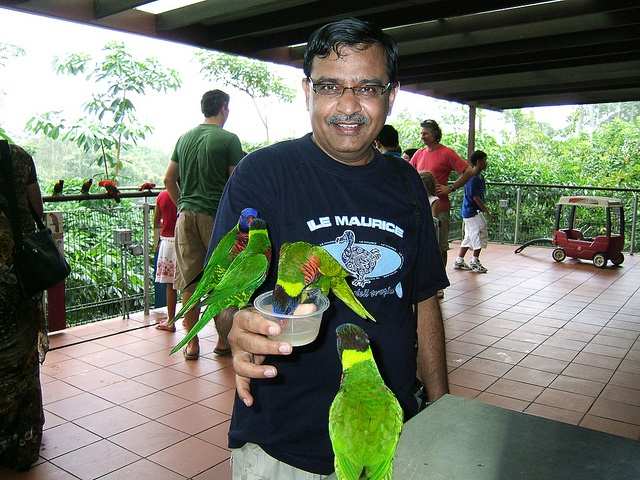Describe the objects in this image and their specific colors. I can see people in black, gray, and tan tones, people in black, gray, ivory, and darkgreen tones, people in black, gray, and darkgreen tones, bird in black, green, lime, and lightgreen tones, and bird in black, olive, and darkgreen tones in this image. 